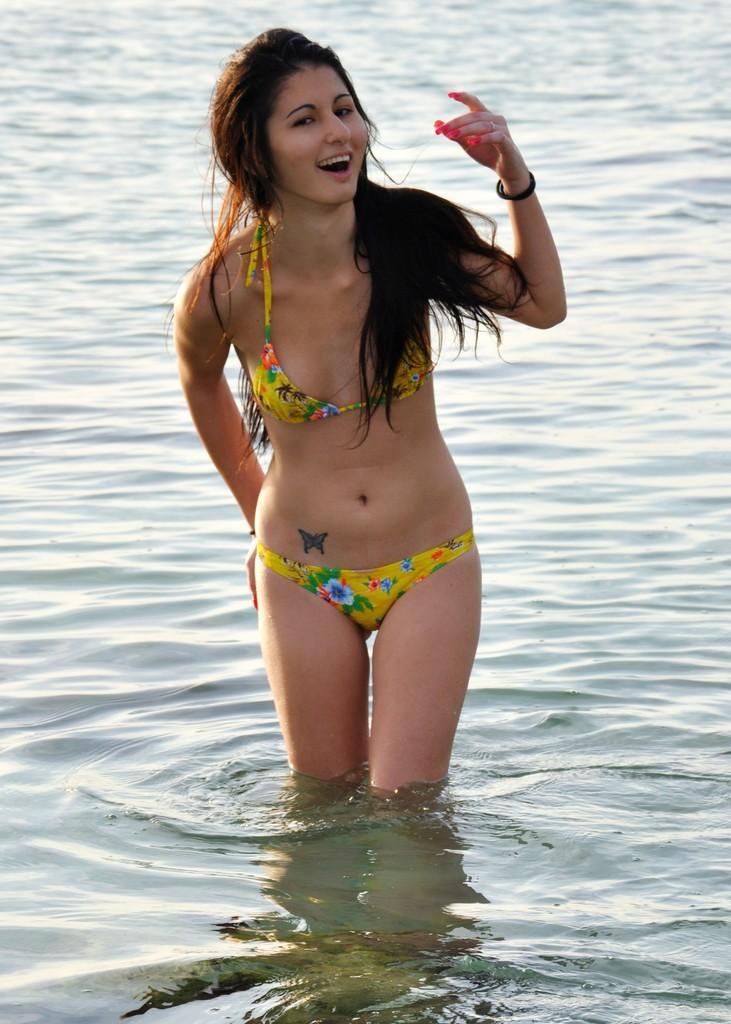Who is present in the image? There is a woman in the image. What is the woman doing in the image? The woman is standing in the water. What is the woman's facial expression in the image? The woman is smiling. What can be seen at the bottom of the image? There is water visible at the bottom of the image. What type of stitch is the woman using to sew a dress in the image? There is no indication in the image that the woman is sewing a dress or using any type of stitch. 